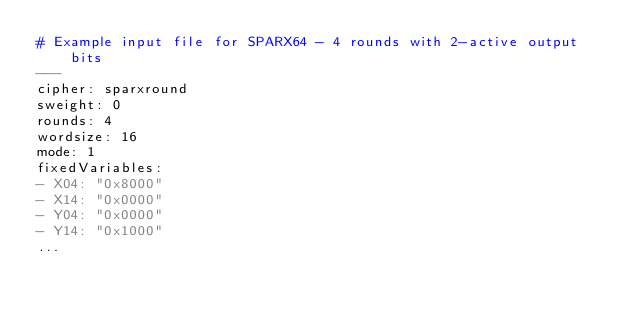Convert code to text. <code><loc_0><loc_0><loc_500><loc_500><_YAML_># Example input file for SPARX64 - 4 rounds with 2-active output bits
---
cipher: sparxround
sweight: 0
rounds: 4
wordsize: 16
mode: 1
fixedVariables:
- X04: "0x8000"
- X14: "0x0000"
- Y04: "0x0000"
- Y14: "0x1000"
...

</code> 